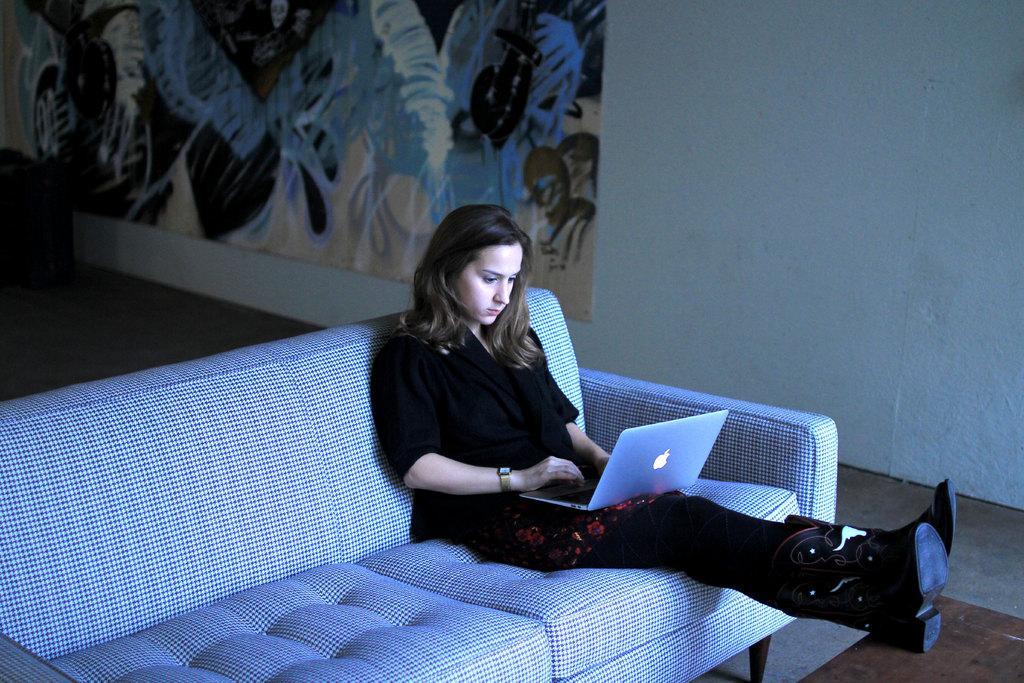In one or two sentences, can you explain what this image depicts? there is a girl sitting on a sofa holding a laptop behind her there is a big painting on the wall. 